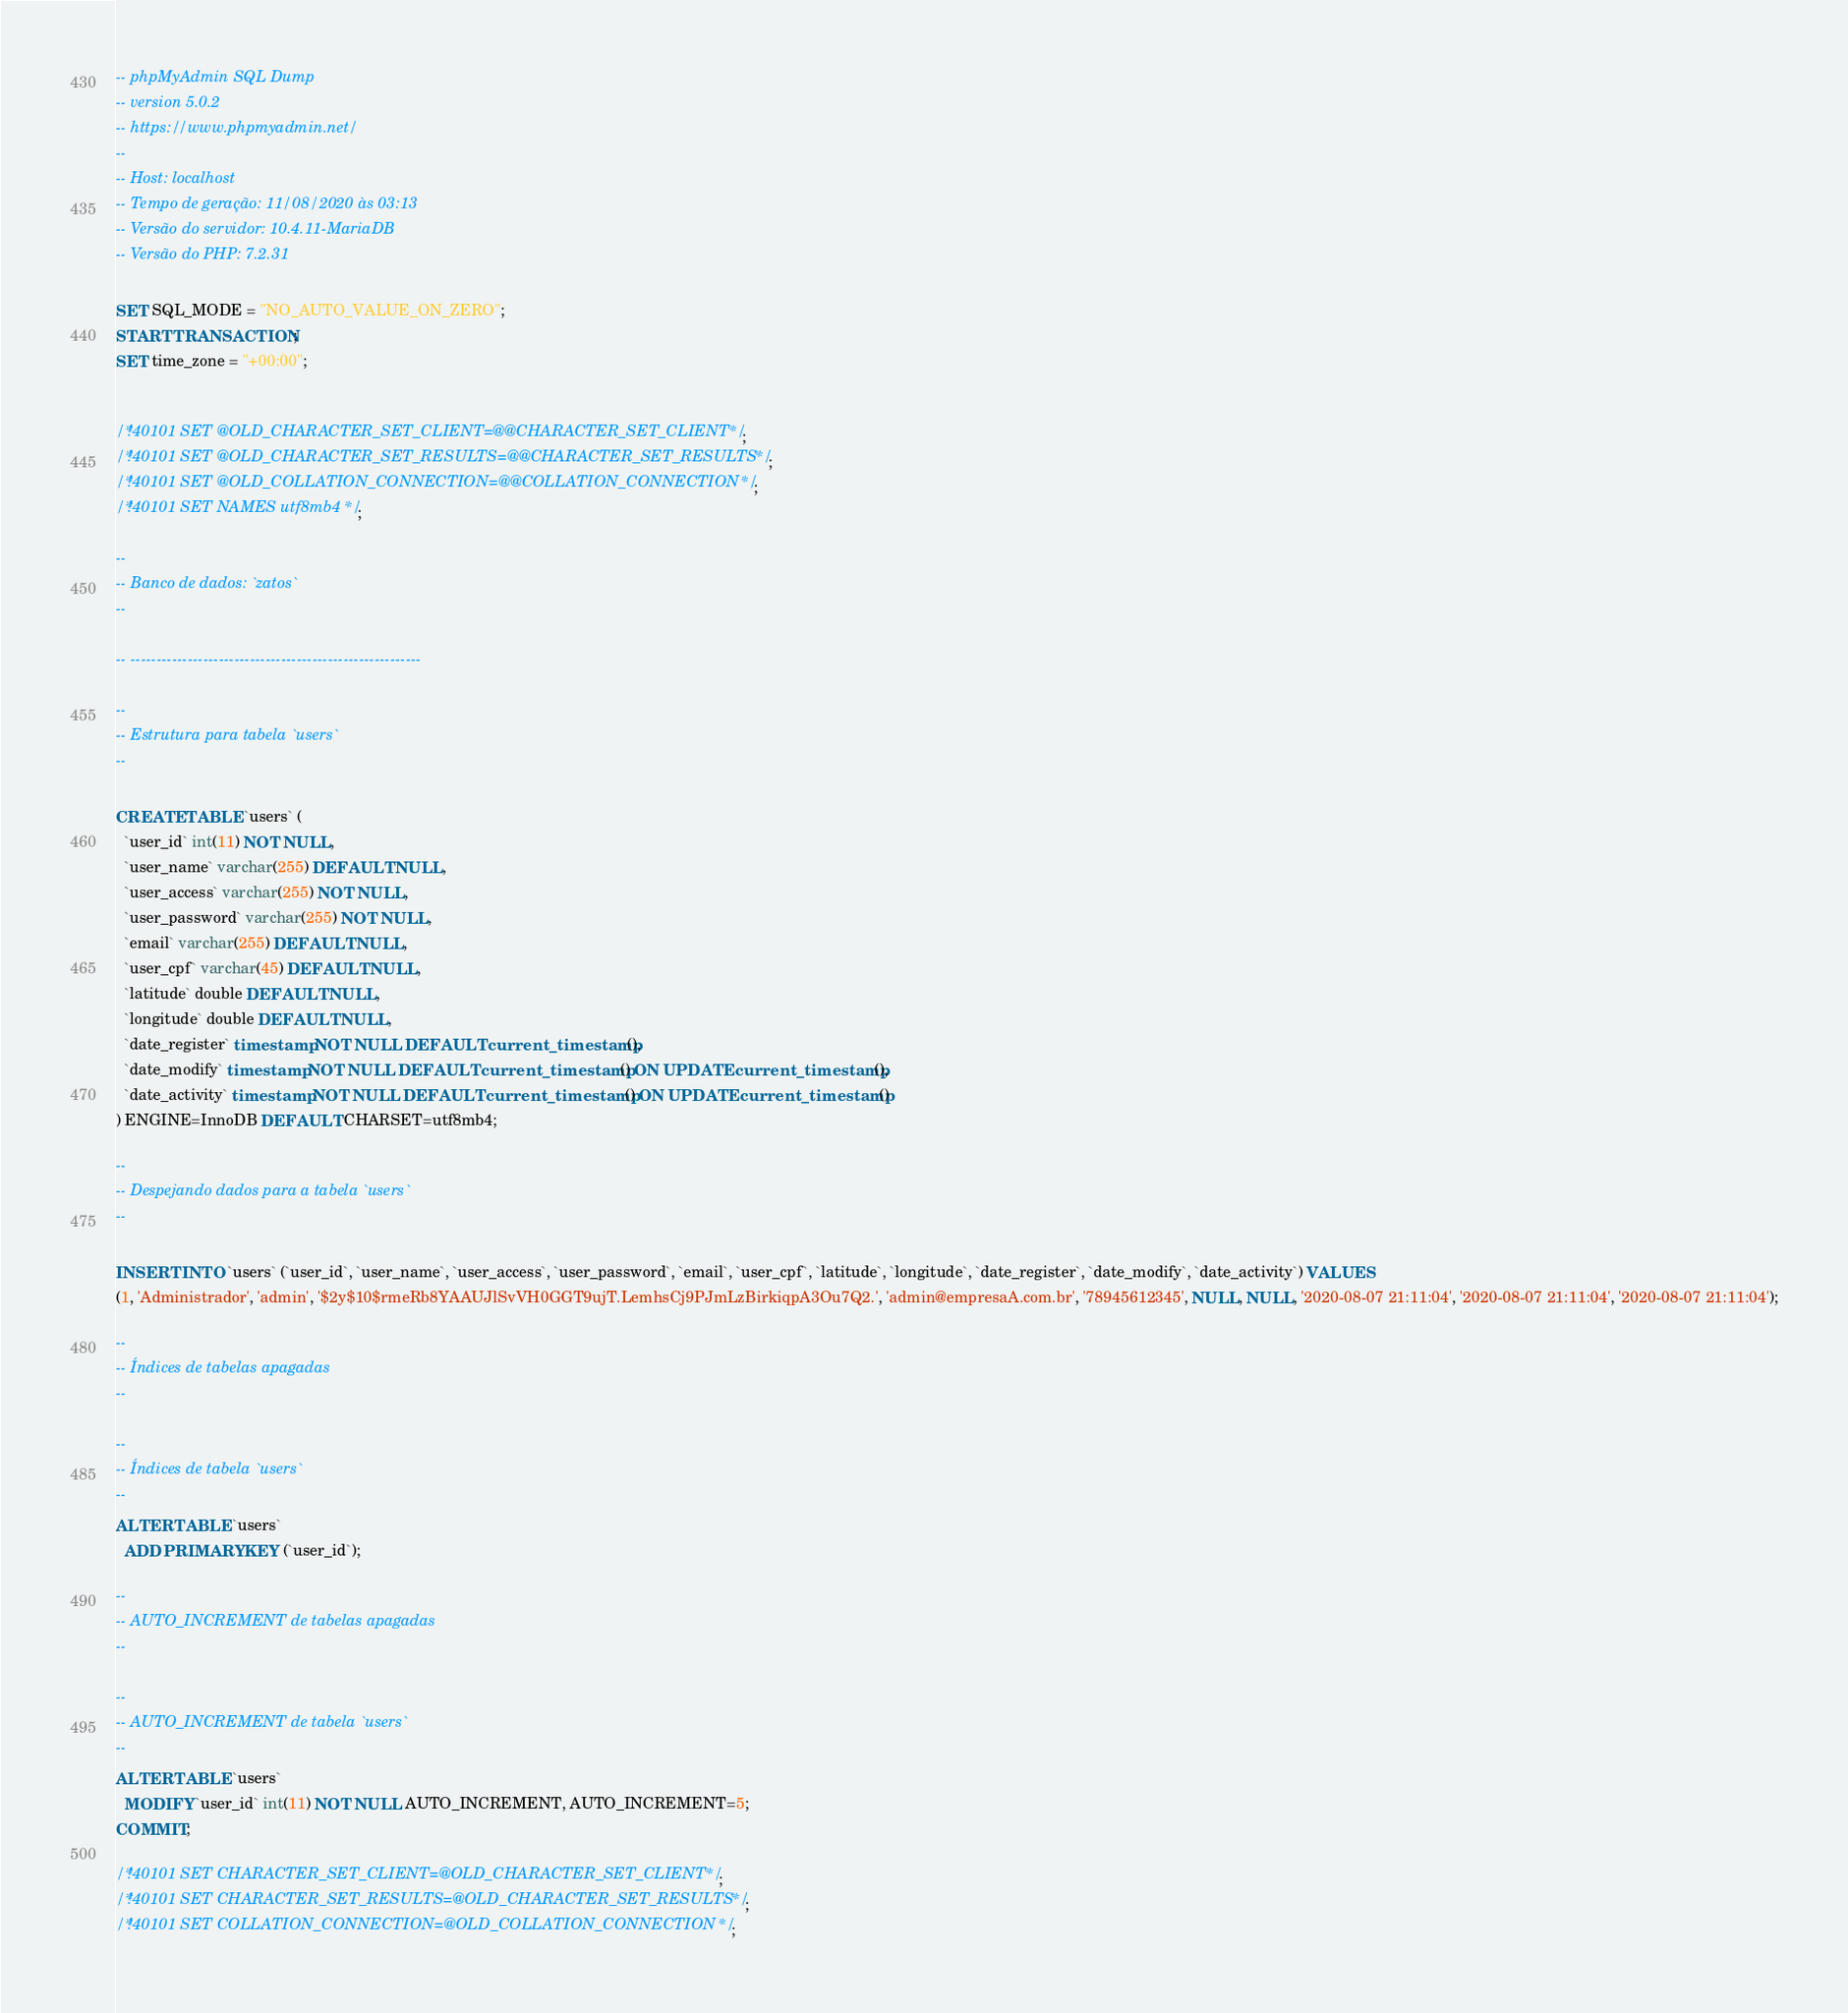Convert code to text. <code><loc_0><loc_0><loc_500><loc_500><_SQL_>-- phpMyAdmin SQL Dump
-- version 5.0.2
-- https://www.phpmyadmin.net/
--
-- Host: localhost
-- Tempo de geração: 11/08/2020 às 03:13
-- Versão do servidor: 10.4.11-MariaDB
-- Versão do PHP: 7.2.31

SET SQL_MODE = "NO_AUTO_VALUE_ON_ZERO";
START TRANSACTION;
SET time_zone = "+00:00";


/*!40101 SET @OLD_CHARACTER_SET_CLIENT=@@CHARACTER_SET_CLIENT */;
/*!40101 SET @OLD_CHARACTER_SET_RESULTS=@@CHARACTER_SET_RESULTS */;
/*!40101 SET @OLD_COLLATION_CONNECTION=@@COLLATION_CONNECTION */;
/*!40101 SET NAMES utf8mb4 */;

--
-- Banco de dados: `zatos`
--

-- --------------------------------------------------------

--
-- Estrutura para tabela `users`
--

CREATE TABLE `users` (
  `user_id` int(11) NOT NULL,
  `user_name` varchar(255) DEFAULT NULL,
  `user_access` varchar(255) NOT NULL,
  `user_password` varchar(255) NOT NULL,
  `email` varchar(255) DEFAULT NULL,
  `user_cpf` varchar(45) DEFAULT NULL,
  `latitude` double DEFAULT NULL,
  `longitude` double DEFAULT NULL,
  `date_register` timestamp NOT NULL DEFAULT current_timestamp(),
  `date_modify` timestamp NOT NULL DEFAULT current_timestamp() ON UPDATE current_timestamp(),
  `date_activity` timestamp NOT NULL DEFAULT current_timestamp() ON UPDATE current_timestamp()
) ENGINE=InnoDB DEFAULT CHARSET=utf8mb4;

--
-- Despejando dados para a tabela `users`
--

INSERT INTO `users` (`user_id`, `user_name`, `user_access`, `user_password`, `email`, `user_cpf`, `latitude`, `longitude`, `date_register`, `date_modify`, `date_activity`) VALUES
(1, 'Administrador', 'admin', '$2y$10$rmeRb8YAAUJlSvVH0GGT9ujT.LemhsCj9PJmLzBirkiqpA3Ou7Q2.', 'admin@empresaA.com.br', '78945612345', NULL, NULL, '2020-08-07 21:11:04', '2020-08-07 21:11:04', '2020-08-07 21:11:04');

--
-- Índices de tabelas apagadas
--

--
-- Índices de tabela `users`
--
ALTER TABLE `users`
  ADD PRIMARY KEY (`user_id`);

--
-- AUTO_INCREMENT de tabelas apagadas
--

--
-- AUTO_INCREMENT de tabela `users`
--
ALTER TABLE `users`
  MODIFY `user_id` int(11) NOT NULL AUTO_INCREMENT, AUTO_INCREMENT=5;
COMMIT;

/*!40101 SET CHARACTER_SET_CLIENT=@OLD_CHARACTER_SET_CLIENT */;
/*!40101 SET CHARACTER_SET_RESULTS=@OLD_CHARACTER_SET_RESULTS */;
/*!40101 SET COLLATION_CONNECTION=@OLD_COLLATION_CONNECTION */;
</code> 